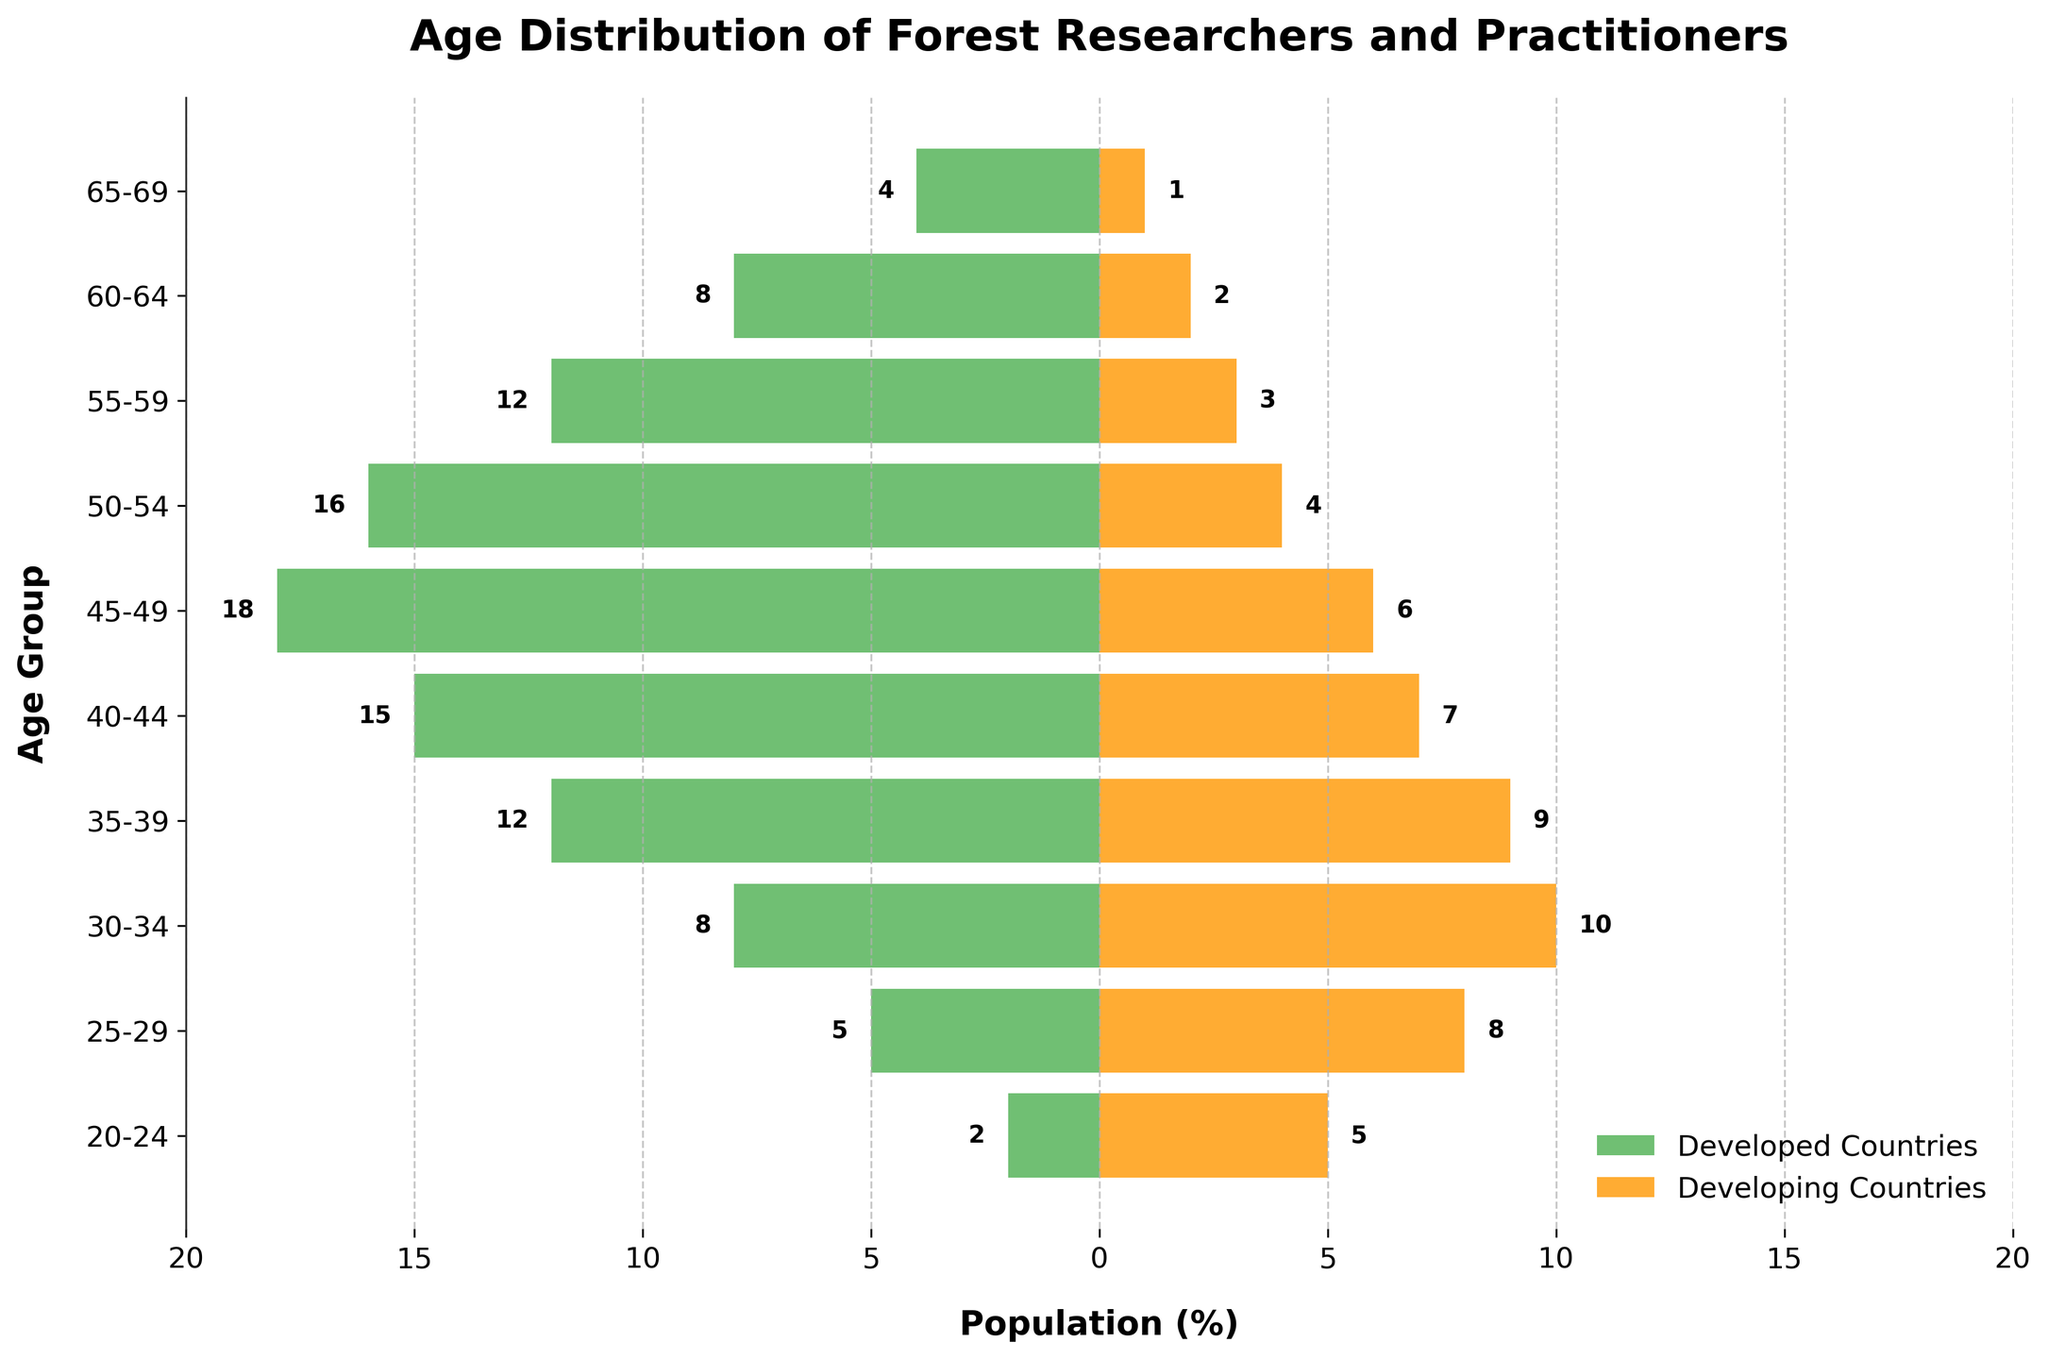What's the title of the figure? The title is found at the top of the figure and is written in bold.
Answer: Age Distribution of Forest Researchers and Practitioners What is the population percentage range visible on the x-axis? The x-axis is labeled 'Population (%)' and shows tick marks from -20 to 20.
Answer: -20 to 20 Which age group has the highest population of forest researchers in developed countries? The bar representing the age group 45-49 is the longest on the left side of the pyramid, indicating it has the highest population percentage in developed countries.
Answer: 45-49 Which color represents developed countries? The legend at the bottom-right corner of the figure indicates that developed countries are represented by the green color.
Answer: Green How many researchers are there in the 30-34 age group in developing countries? Refer to the horizontal orange bar corresponding to the '30-34' age group; the value is labeled on the bar.
Answer: 10 In which age group do developing countries have more researchers than developed countries? Compare the lengths of the orange and green bars. The age groups where the orange bar exceeds the green bar are 20-24, 25-29, 30-34, and 35-39.
Answer: 20-24, 25-29, 30-34, 35-39 What's the difference in the number of researchers in the 40-44 age group between developing and developed countries? The figure shows 15 researchers in developed countries and 7 in developing countries for the 40-44 age group. The difference is calculated as 15 - 7.
Answer: 8 What's the average number of researchers in developed countries across all age groups? Sum the values for developed countries: 2+5+8+12+15+18+16+12+8+4 = 100. There are 10 age groups, so divide the sum by 10: 100/10.
Answer: 10 Are there more researchers aged 50-54 or 60-64 in developed countries? Compare the lengths and the values of bars for age groups 50-54 (16 researchers) and 60-64 (8 researchers). 16 > 8.
Answer: 50-54 What is the total number of researchers in the 55-59 age group across both developed and developing countries? Refer to the bars for 55-59. Developed countries: 12, Developing countries: 3. Add them: 12 + 3.
Answer: 15 